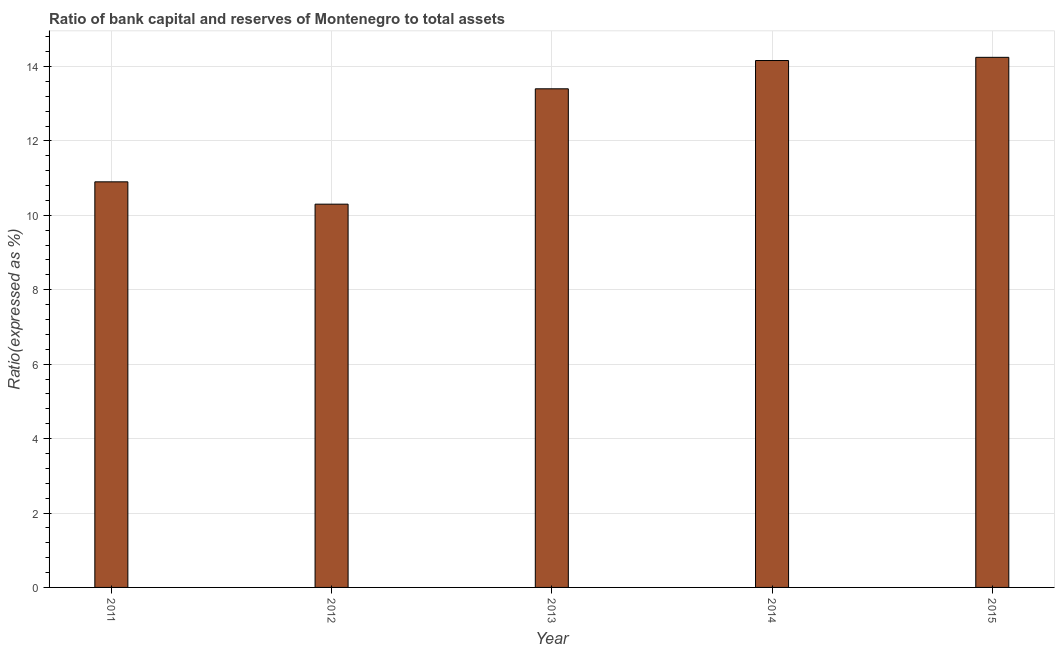Does the graph contain any zero values?
Provide a succinct answer. No. Does the graph contain grids?
Your answer should be compact. Yes. What is the title of the graph?
Keep it short and to the point. Ratio of bank capital and reserves of Montenegro to total assets. What is the label or title of the X-axis?
Keep it short and to the point. Year. What is the label or title of the Y-axis?
Keep it short and to the point. Ratio(expressed as %). Across all years, what is the maximum bank capital to assets ratio?
Ensure brevity in your answer.  14.25. In which year was the bank capital to assets ratio maximum?
Offer a very short reply. 2015. What is the sum of the bank capital to assets ratio?
Provide a succinct answer. 63.01. What is the difference between the bank capital to assets ratio in 2014 and 2015?
Keep it short and to the point. -0.09. What is the average bank capital to assets ratio per year?
Your answer should be very brief. 12.6. In how many years, is the bank capital to assets ratio greater than 4.4 %?
Give a very brief answer. 5. What is the ratio of the bank capital to assets ratio in 2012 to that in 2013?
Provide a succinct answer. 0.77. Is the bank capital to assets ratio in 2011 less than that in 2015?
Offer a very short reply. Yes. What is the difference between the highest and the second highest bank capital to assets ratio?
Give a very brief answer. 0.09. What is the difference between the highest and the lowest bank capital to assets ratio?
Offer a very short reply. 3.95. In how many years, is the bank capital to assets ratio greater than the average bank capital to assets ratio taken over all years?
Keep it short and to the point. 3. How many bars are there?
Your answer should be compact. 5. Are all the bars in the graph horizontal?
Offer a very short reply. No. What is the difference between two consecutive major ticks on the Y-axis?
Your answer should be very brief. 2. Are the values on the major ticks of Y-axis written in scientific E-notation?
Your answer should be compact. No. What is the Ratio(expressed as %) in 2014?
Give a very brief answer. 14.16. What is the Ratio(expressed as %) of 2015?
Provide a succinct answer. 14.25. What is the difference between the Ratio(expressed as %) in 2011 and 2012?
Make the answer very short. 0.6. What is the difference between the Ratio(expressed as %) in 2011 and 2014?
Ensure brevity in your answer.  -3.26. What is the difference between the Ratio(expressed as %) in 2011 and 2015?
Your response must be concise. -3.35. What is the difference between the Ratio(expressed as %) in 2012 and 2014?
Make the answer very short. -3.86. What is the difference between the Ratio(expressed as %) in 2012 and 2015?
Make the answer very short. -3.95. What is the difference between the Ratio(expressed as %) in 2013 and 2014?
Keep it short and to the point. -0.76. What is the difference between the Ratio(expressed as %) in 2013 and 2015?
Provide a short and direct response. -0.85. What is the difference between the Ratio(expressed as %) in 2014 and 2015?
Your response must be concise. -0.09. What is the ratio of the Ratio(expressed as %) in 2011 to that in 2012?
Offer a terse response. 1.06. What is the ratio of the Ratio(expressed as %) in 2011 to that in 2013?
Your answer should be very brief. 0.81. What is the ratio of the Ratio(expressed as %) in 2011 to that in 2014?
Your answer should be very brief. 0.77. What is the ratio of the Ratio(expressed as %) in 2011 to that in 2015?
Offer a terse response. 0.77. What is the ratio of the Ratio(expressed as %) in 2012 to that in 2013?
Ensure brevity in your answer.  0.77. What is the ratio of the Ratio(expressed as %) in 2012 to that in 2014?
Provide a succinct answer. 0.73. What is the ratio of the Ratio(expressed as %) in 2012 to that in 2015?
Keep it short and to the point. 0.72. What is the ratio of the Ratio(expressed as %) in 2013 to that in 2014?
Your answer should be compact. 0.95. What is the ratio of the Ratio(expressed as %) in 2013 to that in 2015?
Your answer should be compact. 0.94. 